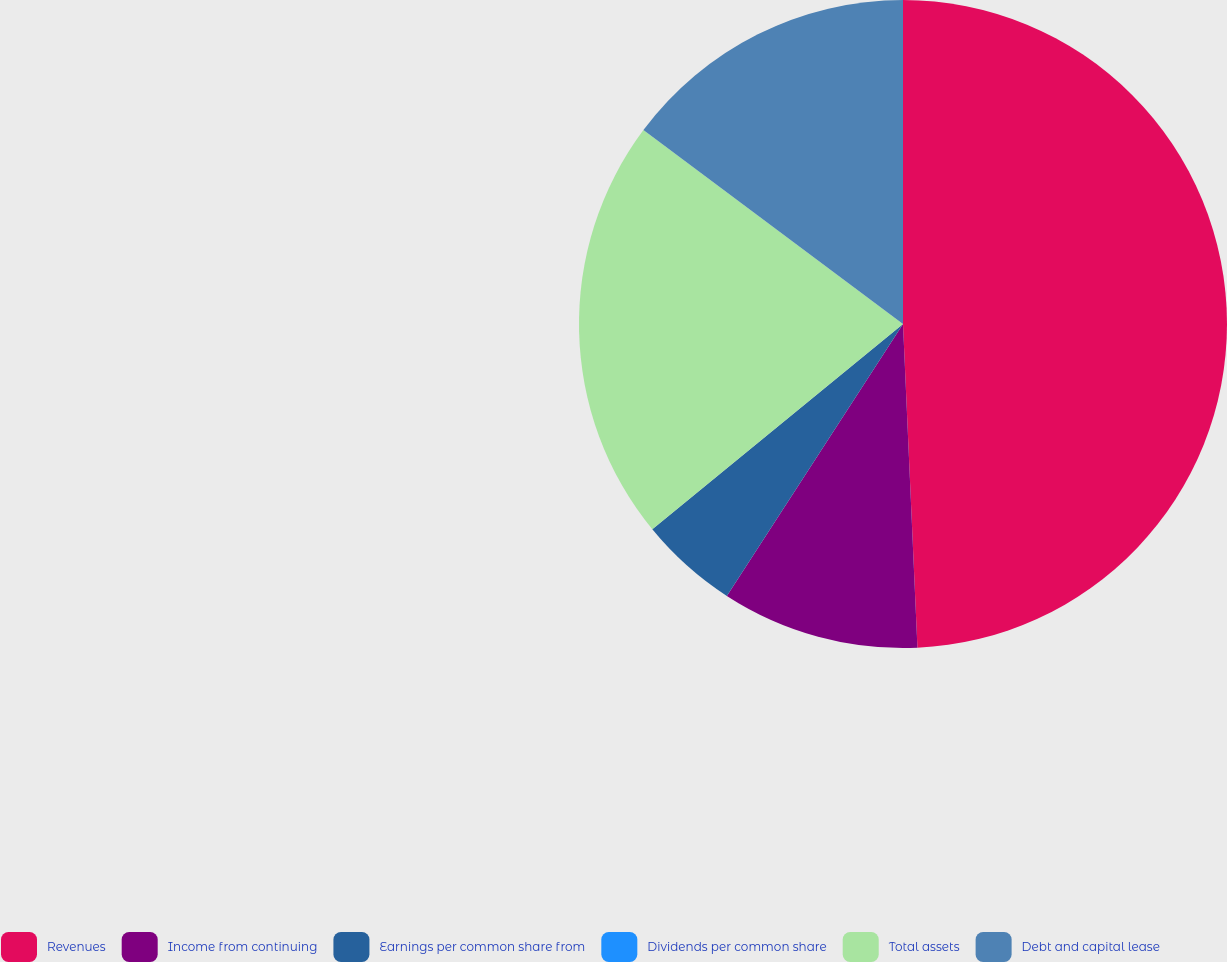Convert chart to OTSL. <chart><loc_0><loc_0><loc_500><loc_500><pie_chart><fcel>Revenues<fcel>Income from continuing<fcel>Earnings per common share from<fcel>Dividends per common share<fcel>Total assets<fcel>Debt and capital lease<nl><fcel>49.29%<fcel>9.86%<fcel>4.93%<fcel>0.0%<fcel>21.13%<fcel>14.79%<nl></chart> 